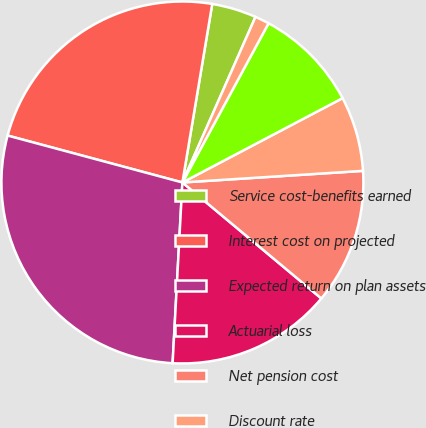<chart> <loc_0><loc_0><loc_500><loc_500><pie_chart><fcel>Service cost-benefits earned<fcel>Interest cost on projected<fcel>Expected return on plan assets<fcel>Actuarial loss<fcel>Net pension cost<fcel>Discount rate<fcel>Long-term rate of return on<fcel>Long-term rate of compensation<nl><fcel>3.98%<fcel>23.46%<fcel>28.31%<fcel>14.79%<fcel>12.09%<fcel>6.69%<fcel>9.39%<fcel>1.28%<nl></chart> 